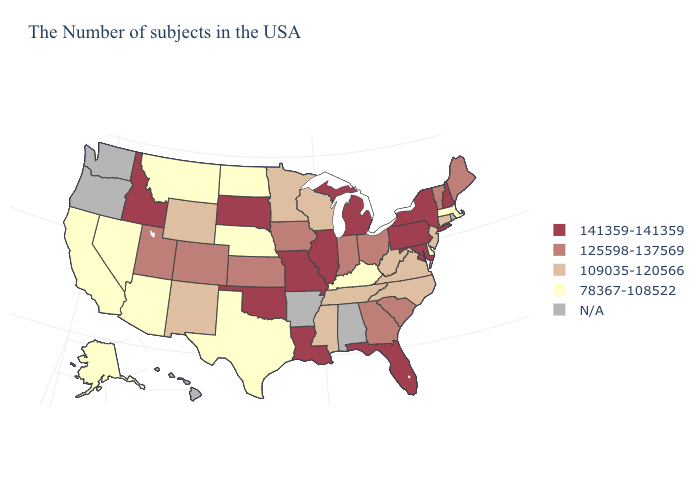Among the states that border South Carolina , does Georgia have the highest value?
Quick response, please. Yes. What is the lowest value in the USA?
Answer briefly. 78367-108522. Among the states that border Kentucky , does Ohio have the lowest value?
Keep it brief. No. Name the states that have a value in the range 78367-108522?
Be succinct. Massachusetts, Delaware, Kentucky, Nebraska, Texas, North Dakota, Montana, Arizona, Nevada, California, Alaska. What is the highest value in the MidWest ?
Concise answer only. 141359-141359. Does New York have the lowest value in the USA?
Concise answer only. No. Name the states that have a value in the range 78367-108522?
Short answer required. Massachusetts, Delaware, Kentucky, Nebraska, Texas, North Dakota, Montana, Arizona, Nevada, California, Alaska. Among the states that border Vermont , does New Hampshire have the lowest value?
Keep it brief. No. Name the states that have a value in the range N/A?
Be succinct. Rhode Island, Alabama, Arkansas, Washington, Oregon, Hawaii. Name the states that have a value in the range 141359-141359?
Concise answer only. New Hampshire, New York, Maryland, Pennsylvania, Florida, Michigan, Illinois, Louisiana, Missouri, Oklahoma, South Dakota, Idaho. Name the states that have a value in the range 125598-137569?
Give a very brief answer. Maine, Vermont, South Carolina, Ohio, Georgia, Indiana, Iowa, Kansas, Colorado, Utah. Which states have the lowest value in the USA?
Concise answer only. Massachusetts, Delaware, Kentucky, Nebraska, Texas, North Dakota, Montana, Arizona, Nevada, California, Alaska. Does Massachusetts have the lowest value in the Northeast?
Quick response, please. Yes. What is the highest value in the USA?
Concise answer only. 141359-141359. 